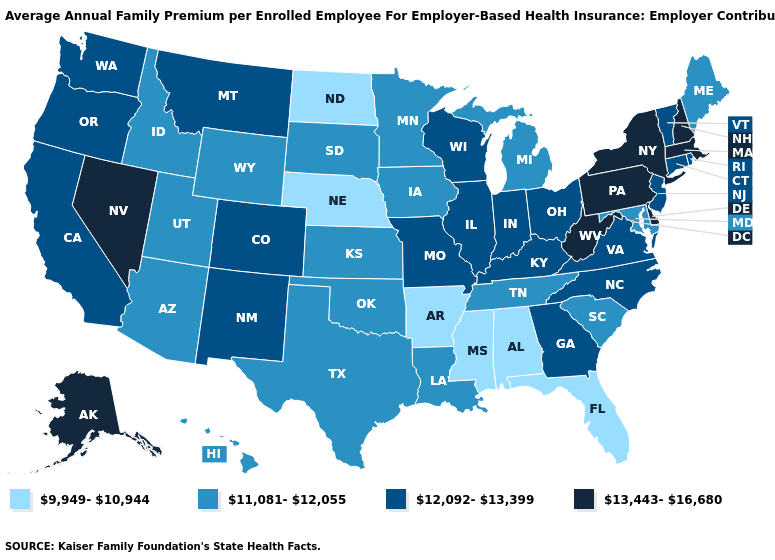Name the states that have a value in the range 13,443-16,680?
Concise answer only. Alaska, Delaware, Massachusetts, Nevada, New Hampshire, New York, Pennsylvania, West Virginia. Name the states that have a value in the range 13,443-16,680?
Keep it brief. Alaska, Delaware, Massachusetts, Nevada, New Hampshire, New York, Pennsylvania, West Virginia. How many symbols are there in the legend?
Write a very short answer. 4. Among the states that border Idaho , does Utah have the lowest value?
Give a very brief answer. Yes. Among the states that border Alabama , which have the highest value?
Short answer required. Georgia. What is the value of Nevada?
Concise answer only. 13,443-16,680. What is the lowest value in the USA?
Keep it brief. 9,949-10,944. Which states hav the highest value in the West?
Short answer required. Alaska, Nevada. Among the states that border Connecticut , does Massachusetts have the highest value?
Keep it brief. Yes. What is the value of Oregon?
Give a very brief answer. 12,092-13,399. What is the value of Virginia?
Be succinct. 12,092-13,399. Does Hawaii have the lowest value in the West?
Short answer required. Yes. What is the value of Arizona?
Keep it brief. 11,081-12,055. Does the map have missing data?
Answer briefly. No. Among the states that border Utah , which have the highest value?
Quick response, please. Nevada. 